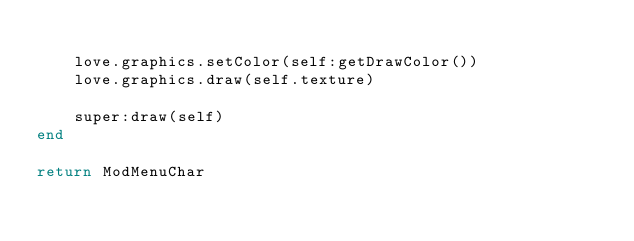Convert code to text. <code><loc_0><loc_0><loc_500><loc_500><_Lua_>
    love.graphics.setColor(self:getDrawColor())
    love.graphics.draw(self.texture)

    super:draw(self)
end

return ModMenuChar</code> 